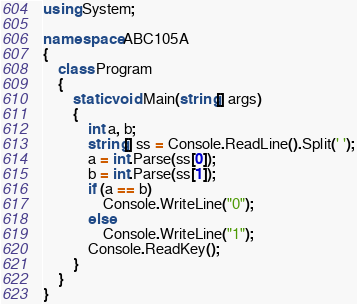Convert code to text. <code><loc_0><loc_0><loc_500><loc_500><_C#_>using System;

namespace ABC105A
{
    class Program
    {
        static void Main(string[] args)
        {
            int a, b;
            string[] ss = Console.ReadLine().Split(' ');
            a = int.Parse(ss[0]);
            b = int.Parse(ss[1]);
            if (a == b)
                Console.WriteLine("0");
            else
                Console.WriteLine("1");
            Console.ReadKey();
        }
    }
}
</code> 